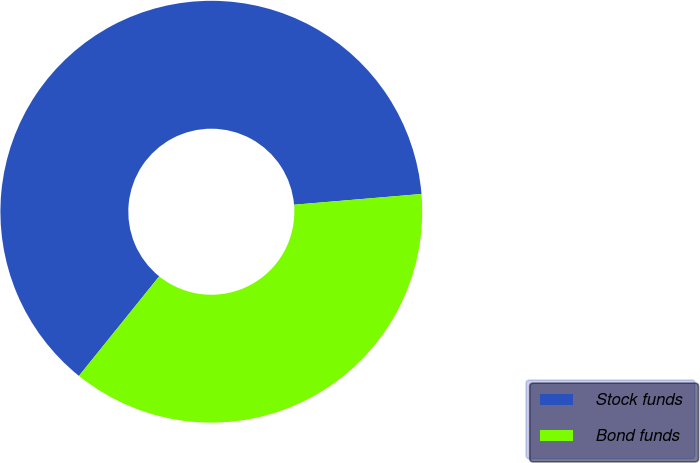Convert chart to OTSL. <chart><loc_0><loc_0><loc_500><loc_500><pie_chart><fcel>Stock funds<fcel>Bond funds<nl><fcel>62.86%<fcel>37.14%<nl></chart> 